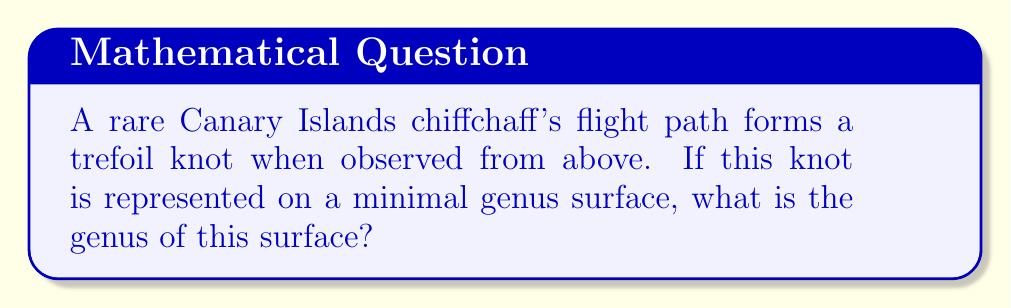Give your solution to this math problem. To determine the genus of a surface on which a knot can be embedded, we can use the following steps:

1. Identify the knot: In this case, we have a trefoil knot.

2. Calculate the crossing number (c) of the knot:
   The trefoil knot has a crossing number of 3.

3. Use the formula for the genus (g) of a knot:
   $$g = \frac{1}{2}(c - 1)$$
   Where c is the crossing number.

4. Substitute the crossing number into the formula:
   $$g = \frac{1}{2}(3 - 1)$$

5. Simplify:
   $$g = \frac{1}{2}(2) = 1$$

Therefore, the genus of the minimal surface on which the trefoil knot (representing the Canary Islands chiffchaff's flight path) can be embedded is 1.

[asy]
import geometry;

size(100);
path p = (0,0)..(-1,1)..(0,2)..(1,1)..(0,0);
draw(p, blue+1);
draw(shift(0.1,0.1)*p, blue+1);
draw(shift(-0.1,-0.1)*p, blue+1);
label("Trefoil Knot", (0,-0.5), S);
[/asy]
Answer: 1 